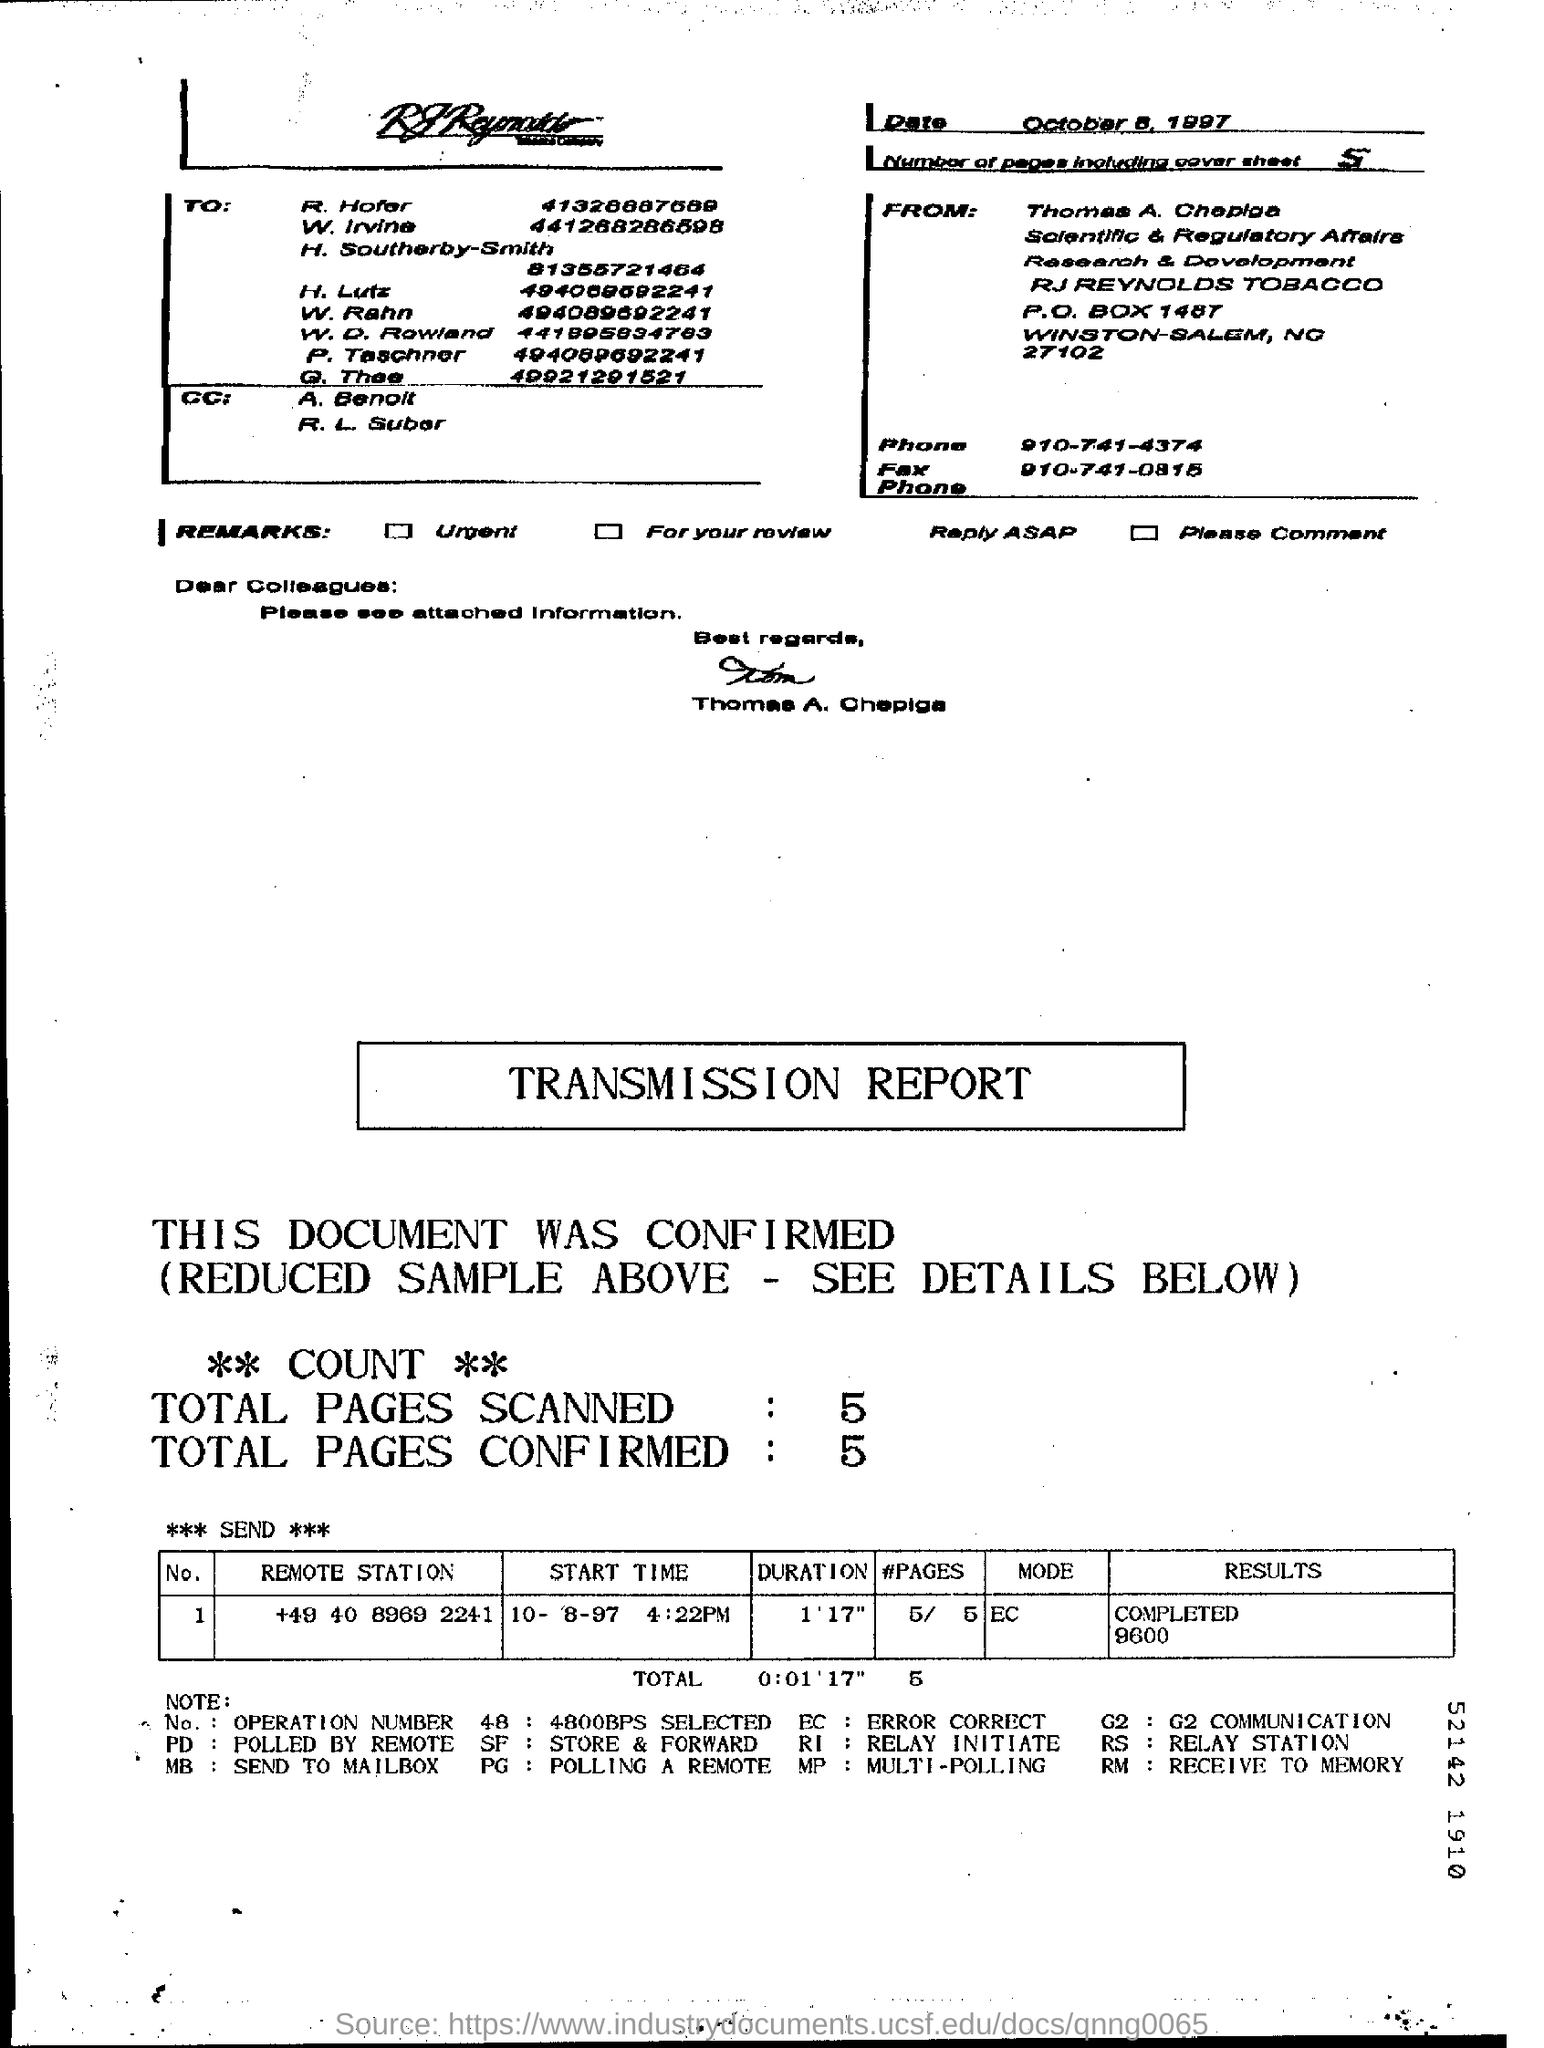How many pages are there including the cover sheet ?
Give a very brief answer. 5. How many total pages are scanned in the transmission report ?
Your response must be concise. 5. How many total pages are confirmed in the transmission report ?
Offer a very short reply. 5. What is the full form of ec?
Provide a short and direct response. Error correct. What is the full form of rs ?
Your answer should be very brief. Relay station. 